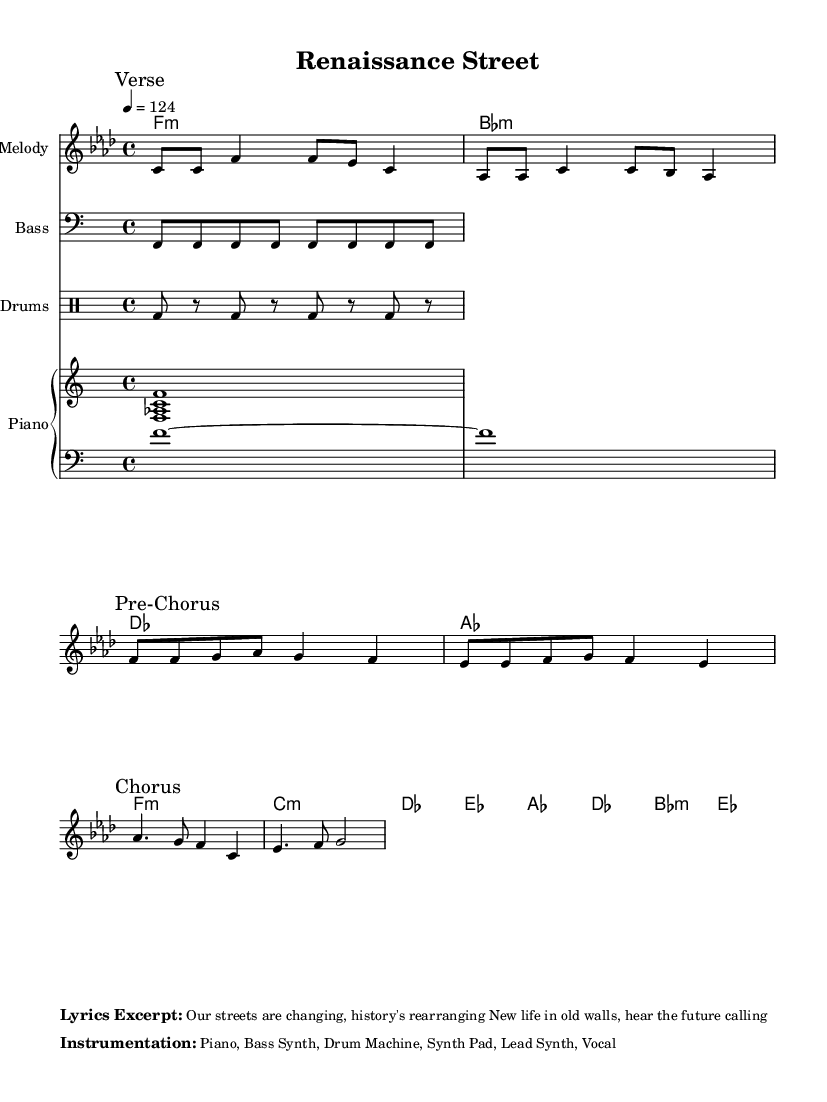What is the key signature of this music? The key signature is indicated at the beginning of the sheet music, which shows that it is in F minor, represented by four flats in its key signature.
Answer: F minor What is the time signature? The time signature appears after the key signature at the start of the sheet music, and it indicates that the piece is set in 4/4 time, meaning there are four beats in each measure.
Answer: 4/4 What is the tempo marking? The tempo marking is found above the melody section and is written as "4 = 124," indicating that there are 124 beats per minute.
Answer: 124 How many measures are in the melody? By counting the measures within the melody notation, it can be observed that there are a total of six measures present.
Answer: 6 What instruments are indicated in the instrumentation? The instrumentation is mentioned in a section towards the end of the sheet music, listing "Piano, Bass Synth, Drum Machine, Synth Pad, Lead Synth, Vocal," which specifies the instruments used in this arrangement.
Answer: Piano, Bass Synth, Drum Machine, Synth Pad, Lead Synth, Vocal What is the first note of the chorus? The chorus starts on an A flat note, which can be identified by looking at the notes written in the melody staff during the section marked "Chorus."
Answer: A flat 